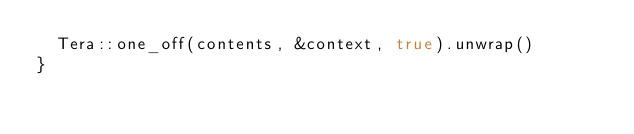<code> <loc_0><loc_0><loc_500><loc_500><_Rust_>	Tera::one_off(contents, &context, true).unwrap()
}
</code> 